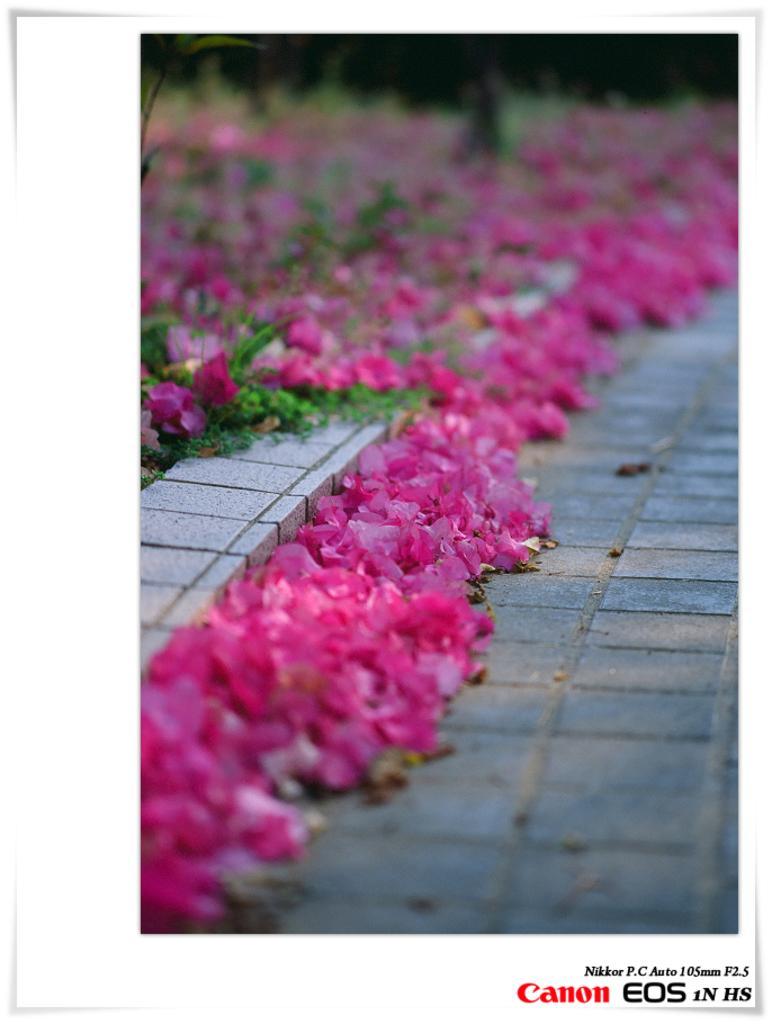In one or two sentences, can you explain what this image depicts? In the image there is a photo on the paper. In that photo on the floor there are flowers and leaves. In the bottom right corner of the image there is text. 